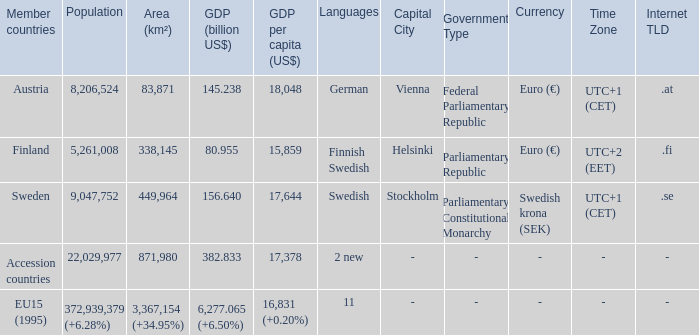Name the member countries for finnish swedish Finland. 